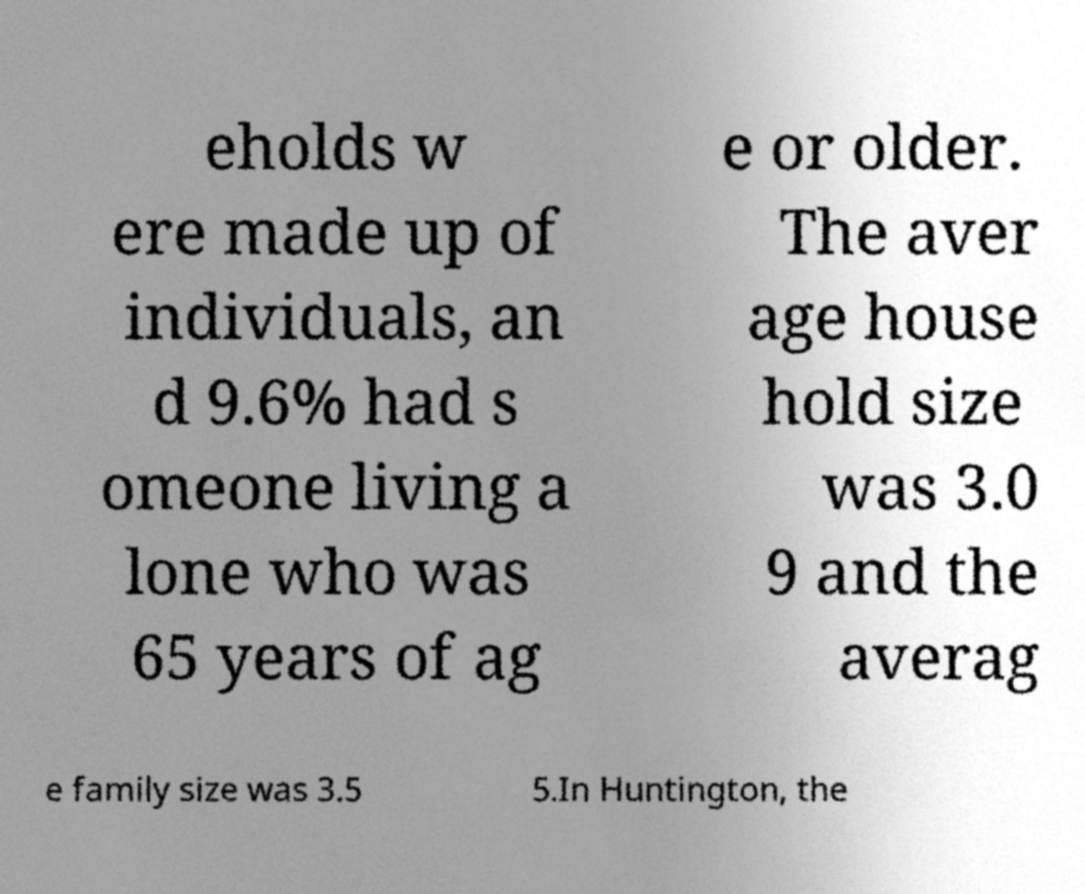I need the written content from this picture converted into text. Can you do that? eholds w ere made up of individuals, an d 9.6% had s omeone living a lone who was 65 years of ag e or older. The aver age house hold size was 3.0 9 and the averag e family size was 3.5 5.In Huntington, the 